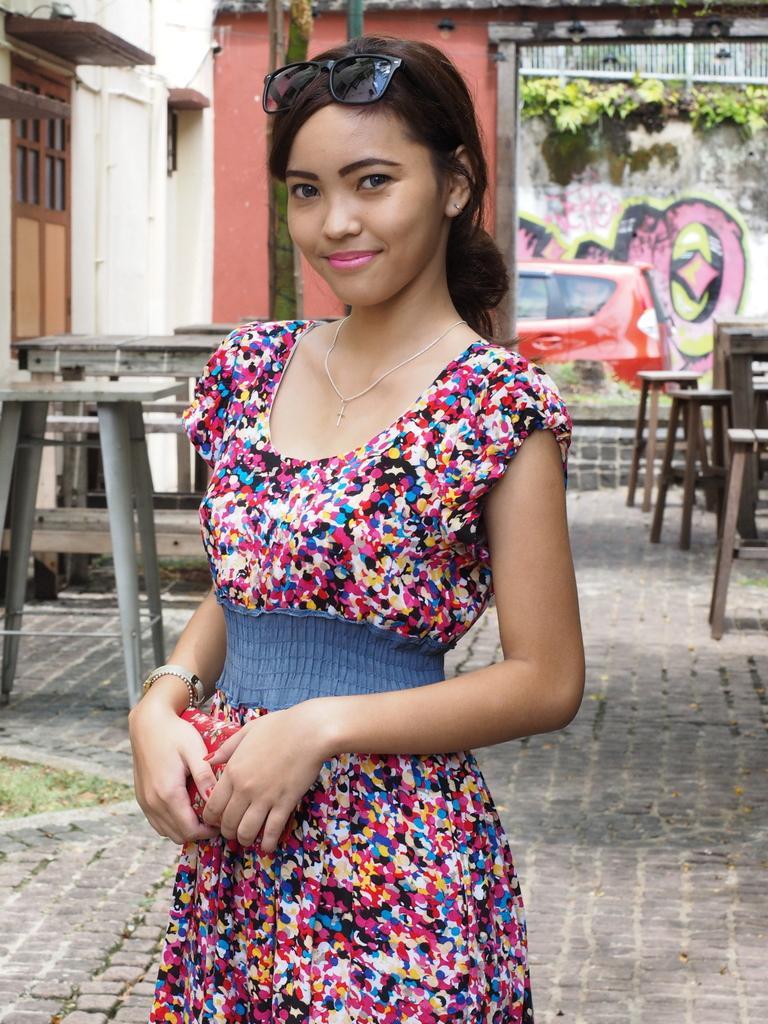Describe this image in one or two sentences. In this image we can see a girl is standing and holding a wallet in her hand and she is having goggles on her head. In the background there are stools, tables, wall, window, vehicles, paintings on the wall and plants. 